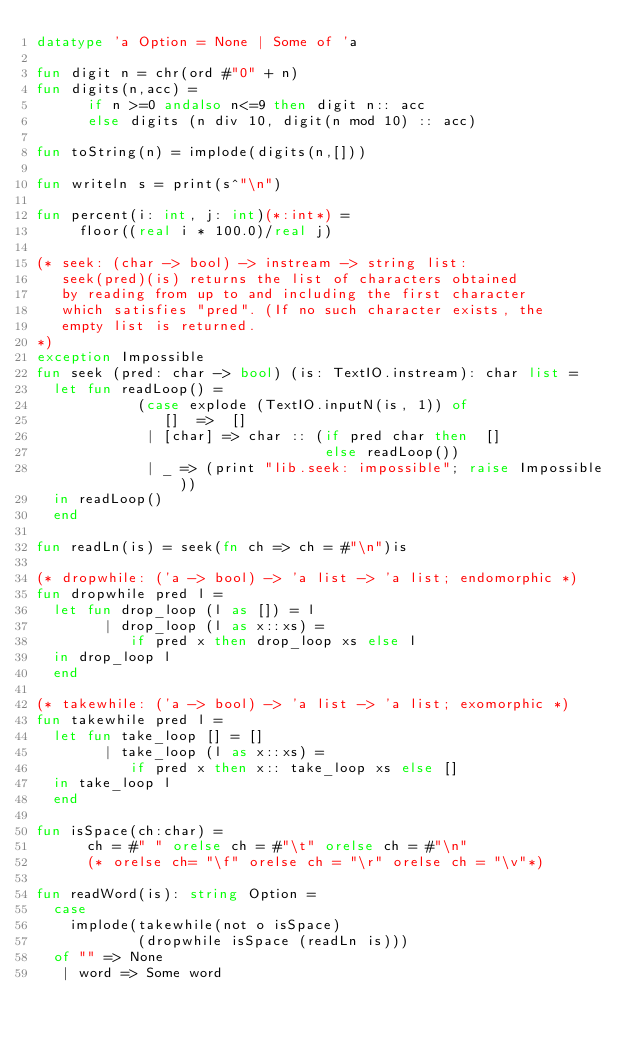Convert code to text. <code><loc_0><loc_0><loc_500><loc_500><_SML_>datatype 'a Option = None | Some of 'a 

fun digit n = chr(ord #"0" + n)
fun digits(n,acc) =
      if n >=0 andalso n<=9 then digit n:: acc
      else digits (n div 10, digit(n mod 10) :: acc)

fun toString(n) = implode(digits(n,[]))

fun writeln s = print(s^"\n")

fun percent(i: int, j: int)(*:int*) = 
     floor((real i * 100.0)/real j) 

(* seek: (char -> bool) -> instream -> string list:
   seek(pred)(is) returns the list of characters obtained
   by reading from up to and including the first character
   which satisfies "pred". (If no such character exists, the
   empty list is returned.
*)
exception Impossible
fun seek (pred: char -> bool) (is: TextIO.instream): char list = 
  let fun readLoop() =
            (case explode (TextIO.inputN(is, 1)) of
               []  =>  []
             | [char] => char :: (if pred char then  []
                                  else readLoop())
             | _ => (print "lib.seek: impossible"; raise Impossible))
  in readLoop()
  end

fun readLn(is) = seek(fn ch => ch = #"\n")is

(* dropwhile: ('a -> bool) -> 'a list -> 'a list; endomorphic *)
fun dropwhile pred l =
  let fun drop_loop (l as []) = l
        | drop_loop (l as x::xs) =
           if pred x then drop_loop xs else l
  in drop_loop l
  end

(* takewhile: ('a -> bool) -> 'a list -> 'a list; exomorphic *)
fun takewhile pred l = 
  let fun take_loop [] = []
        | take_loop (l as x::xs) =
           if pred x then x:: take_loop xs else []
  in take_loop l
  end

fun isSpace(ch:char) = 
      ch = #" " orelse ch = #"\t" orelse ch = #"\n" 
      (* orelse ch= "\f" orelse ch = "\r" orelse ch = "\v"*)

fun readWord(is): string Option =
  case
    implode(takewhile(not o isSpace) 
            (dropwhile isSpace (readLn is)))
  of "" => None
   | word => Some word

        </code> 